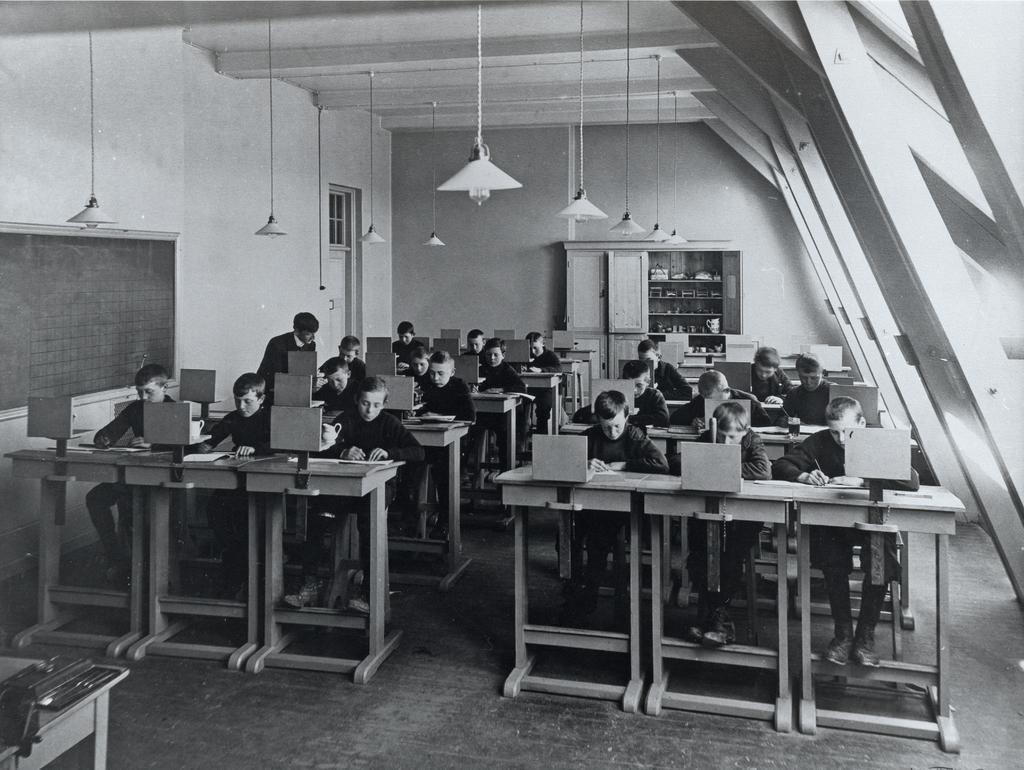Could you give a brief overview of what you see in this image? In this image there are group of persons sitting on the table and doing some work. At the background of the image there is a cupboard,lamps and wall. 